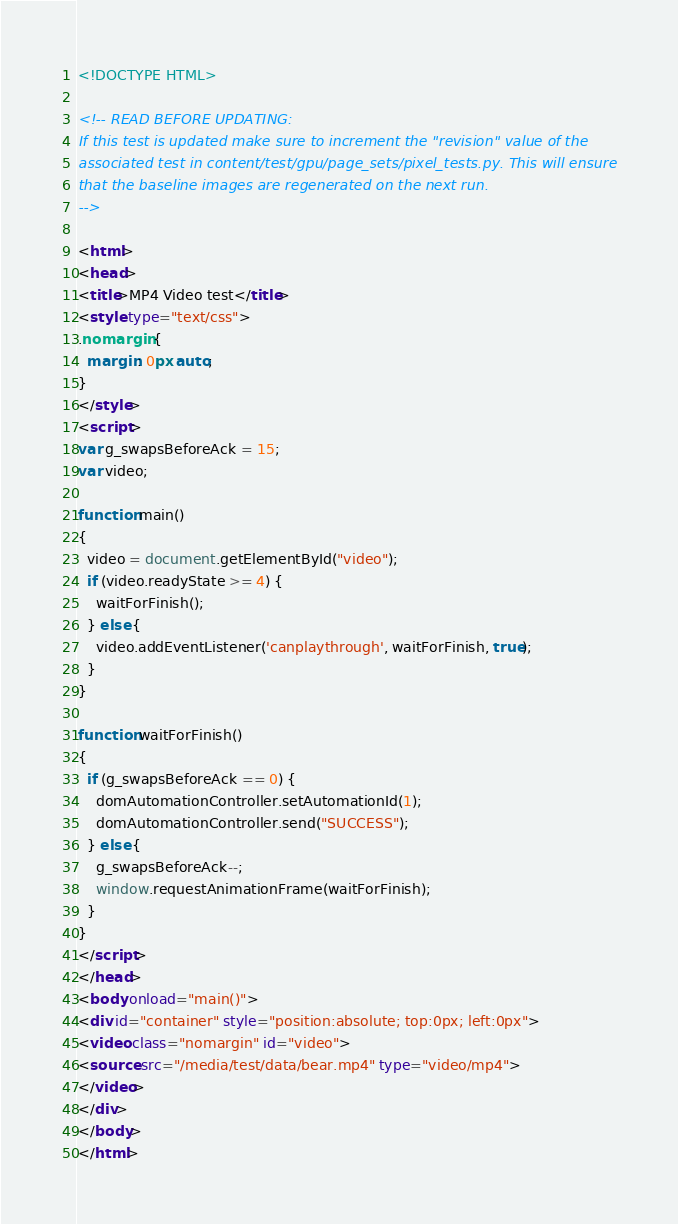Convert code to text. <code><loc_0><loc_0><loc_500><loc_500><_HTML_><!DOCTYPE HTML>

<!-- READ BEFORE UPDATING:
If this test is updated make sure to increment the "revision" value of the
associated test in content/test/gpu/page_sets/pixel_tests.py. This will ensure
that the baseline images are regenerated on the next run.
-->

<html>
<head>
<title>MP4 Video test</title>
<style type="text/css">
.nomargin {
  margin: 0px auto;
}
</style>
<script>
var g_swapsBeforeAck = 15;
var video;

function main()
{
  video = document.getElementById("video");
  if (video.readyState >= 4) {
    waitForFinish();
  } else {
    video.addEventListener('canplaythrough', waitForFinish, true);
  }
}

function waitForFinish()
{
  if (g_swapsBeforeAck == 0) {
    domAutomationController.setAutomationId(1);
    domAutomationController.send("SUCCESS");
  } else {
    g_swapsBeforeAck--;
    window.requestAnimationFrame(waitForFinish);
  }
}
</script>
</head>
<body onload="main()">
<div id="container" style="position:absolute; top:0px; left:0px">
<video class="nomargin" id="video">
<source src="/media/test/data/bear.mp4" type="video/mp4">
</video>
</div>
</body>
</html>
</code> 